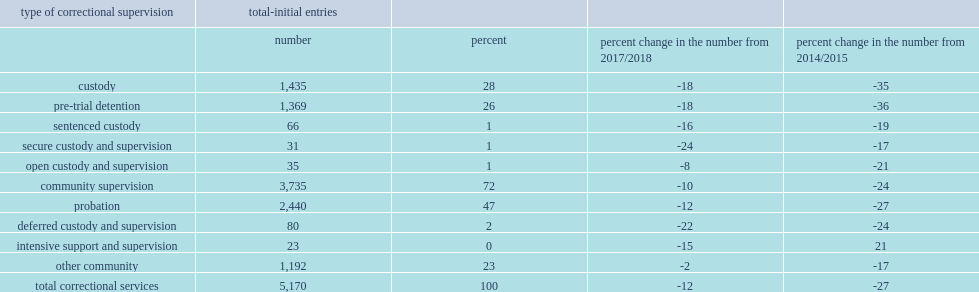In 2018/2019, what is the percentage of youth entered correctional services under community supervision in the reporting jurisdictions of total intial entires? 72.0. In 2018/2019, nearly three in four (72%) youth entered correctional services under community supervision in the reporting jurisdictions of total intial entires, what is the percentage of the decrease from the previous year? 10. What is the percentage of these youth were primarily entering a period of probation? -which includes bail (supervised in saskatchewan and british columbia), non-residential programs, fine options, orders for restitution, compensation or other community or personal services, and other sentences deemed appropriate by the youth justice court. 47.0. What is the percentage of these youth were primarily entering a period of other community supervision? -which includes bail (supervised in saskatchewan and british columbia), non-residential programs, fine options, orders for restitution, compensation or other community or personal services, and other sentences deemed appropriate by the youth justice court. 23.0. What is the percentage of initial entries for youth in the reporting jurisdictions in 2018/2019 of custody? 28.0. What is the percentage of initial entries for youth in the reporting jurisdictions in 2018/2019 of predominantly pre-trial detention.? 26.0. 